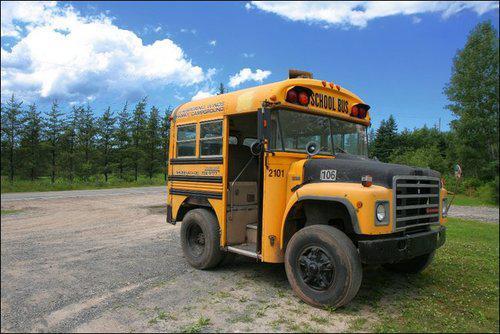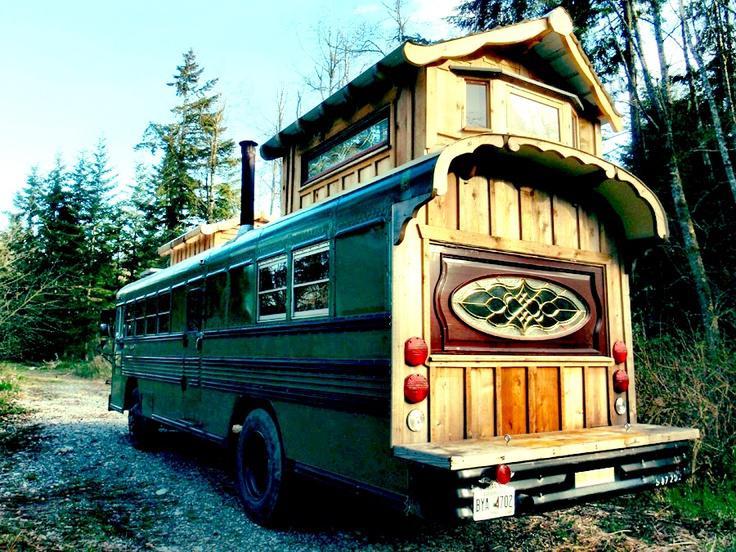The first image is the image on the left, the second image is the image on the right. Given the left and right images, does the statement "Both buses are facing diagonally and to the same side." hold true? Answer yes or no. No. The first image is the image on the left, the second image is the image on the right. Considering the images on both sides, is "Exactly one bus' doors are open." valid? Answer yes or no. Yes. 